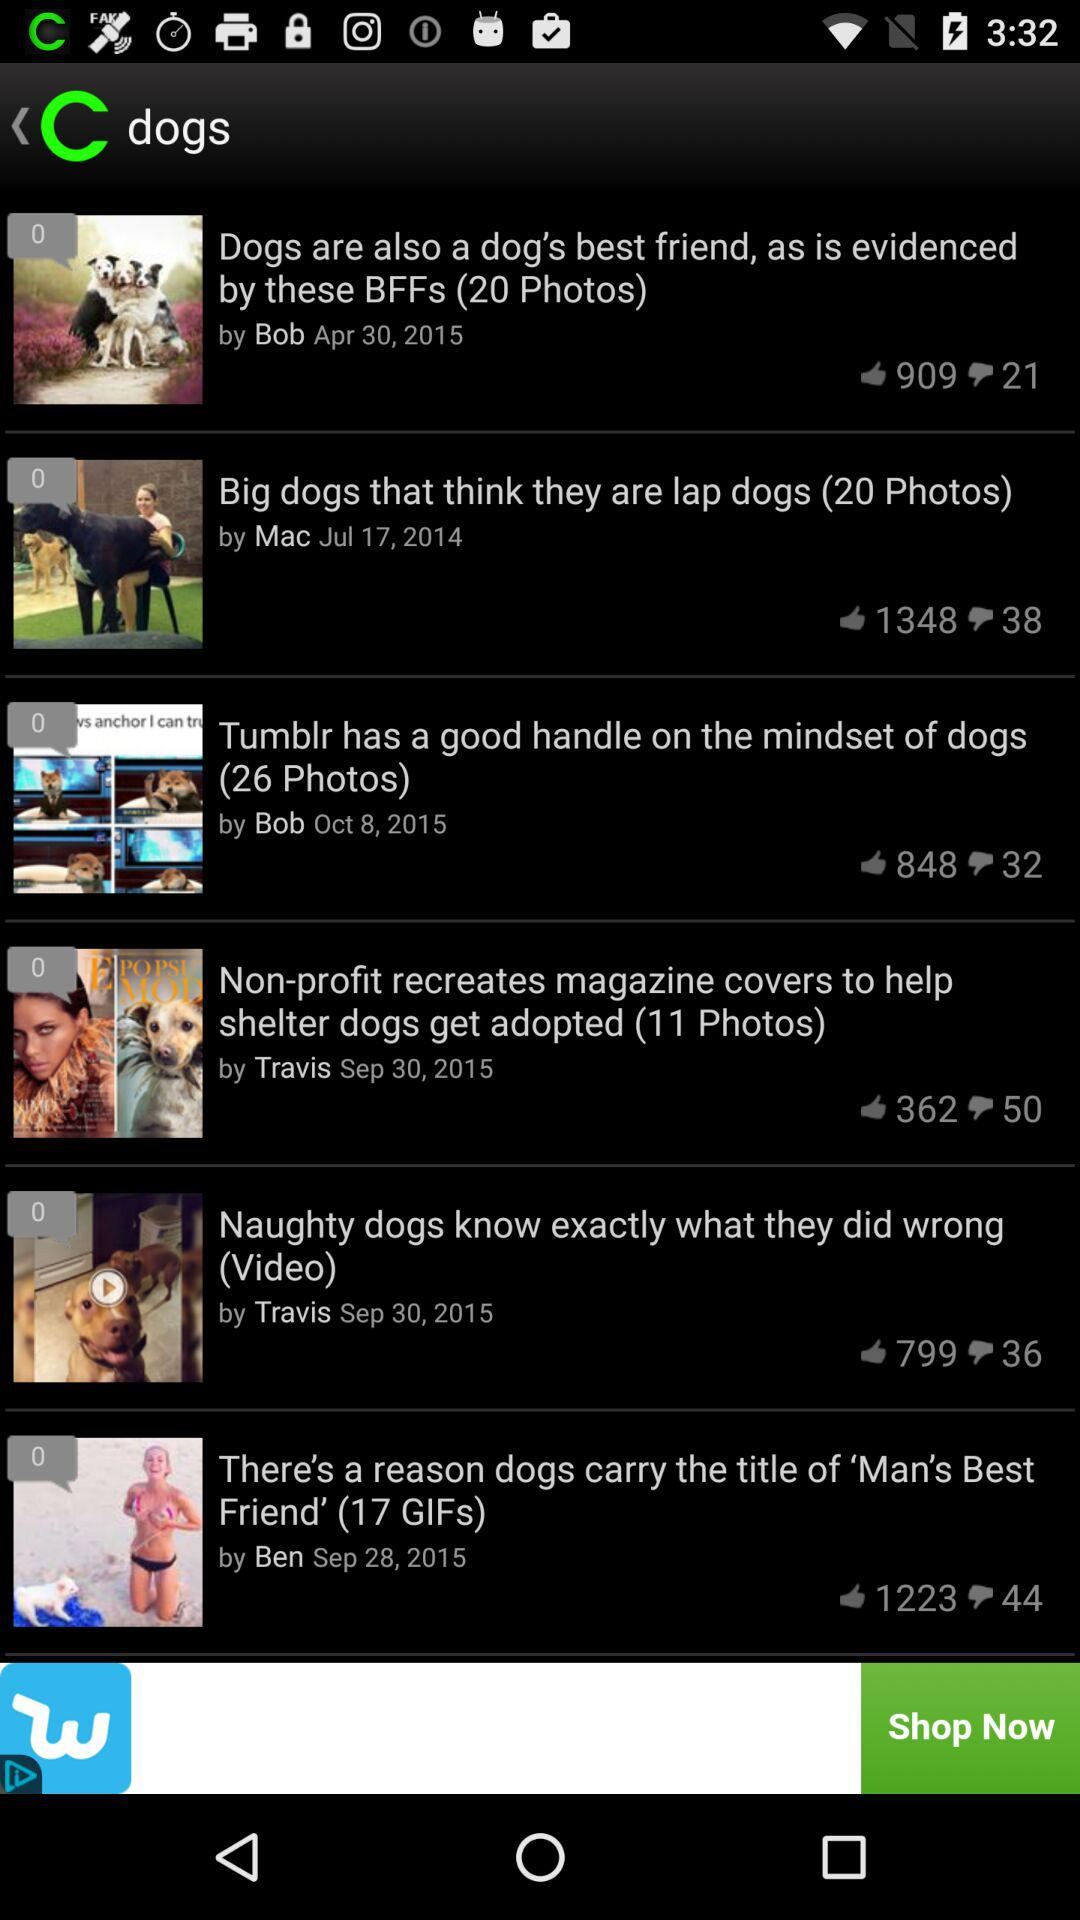How many photos are there in "Tumblr has a good handle on the mindset of dogs"? There are 26 photos. 